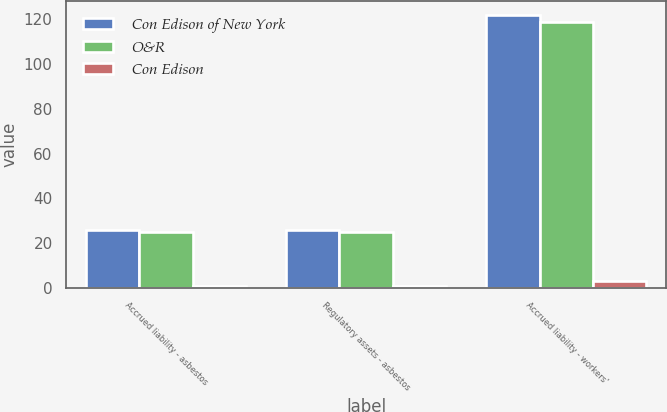<chart> <loc_0><loc_0><loc_500><loc_500><stacked_bar_chart><ecel><fcel>Accrued liability - asbestos<fcel>Regulatory assets - asbestos<fcel>Accrued liability - workers'<nl><fcel>Con Edison of New York<fcel>26<fcel>26<fcel>122<nl><fcel>O&R<fcel>25<fcel>25<fcel>119<nl><fcel>Con Edison<fcel>1<fcel>1<fcel>3<nl></chart> 